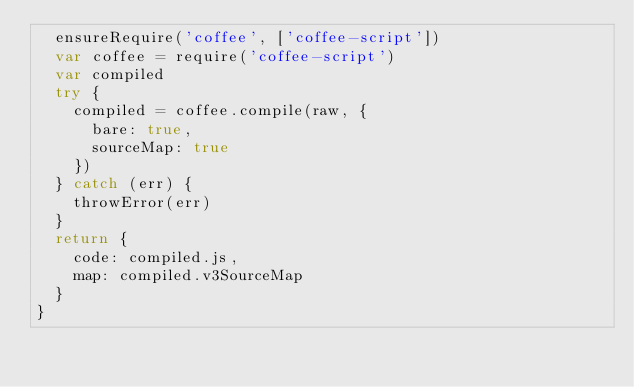Convert code to text. <code><loc_0><loc_0><loc_500><loc_500><_JavaScript_>  ensureRequire('coffee', ['coffee-script'])
  var coffee = require('coffee-script')
  var compiled
  try {
    compiled = coffee.compile(raw, {
      bare: true,
      sourceMap: true
    })
  } catch (err) {
    throwError(err)
  }
  return {
    code: compiled.js,
    map: compiled.v3SourceMap
  }
}
</code> 